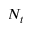<formula> <loc_0><loc_0><loc_500><loc_500>N _ { t }</formula> 